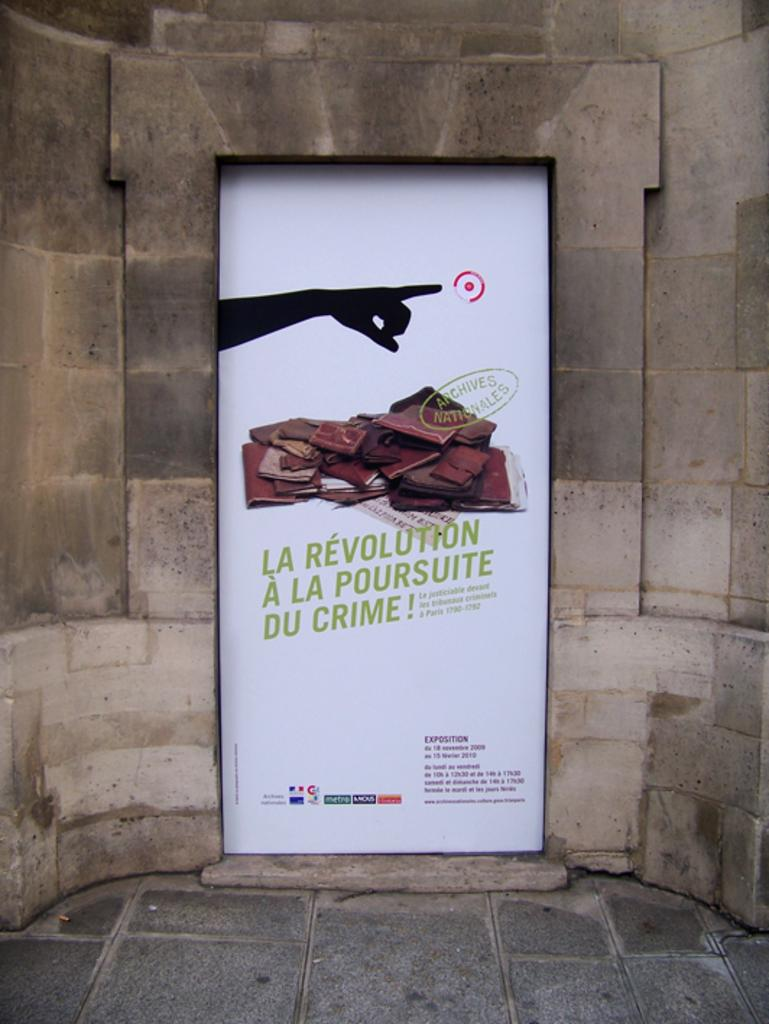<image>
Present a compact description of the photo's key features. A poster promoting La Revolution a la Poursuite Du crime has stark imagery. 